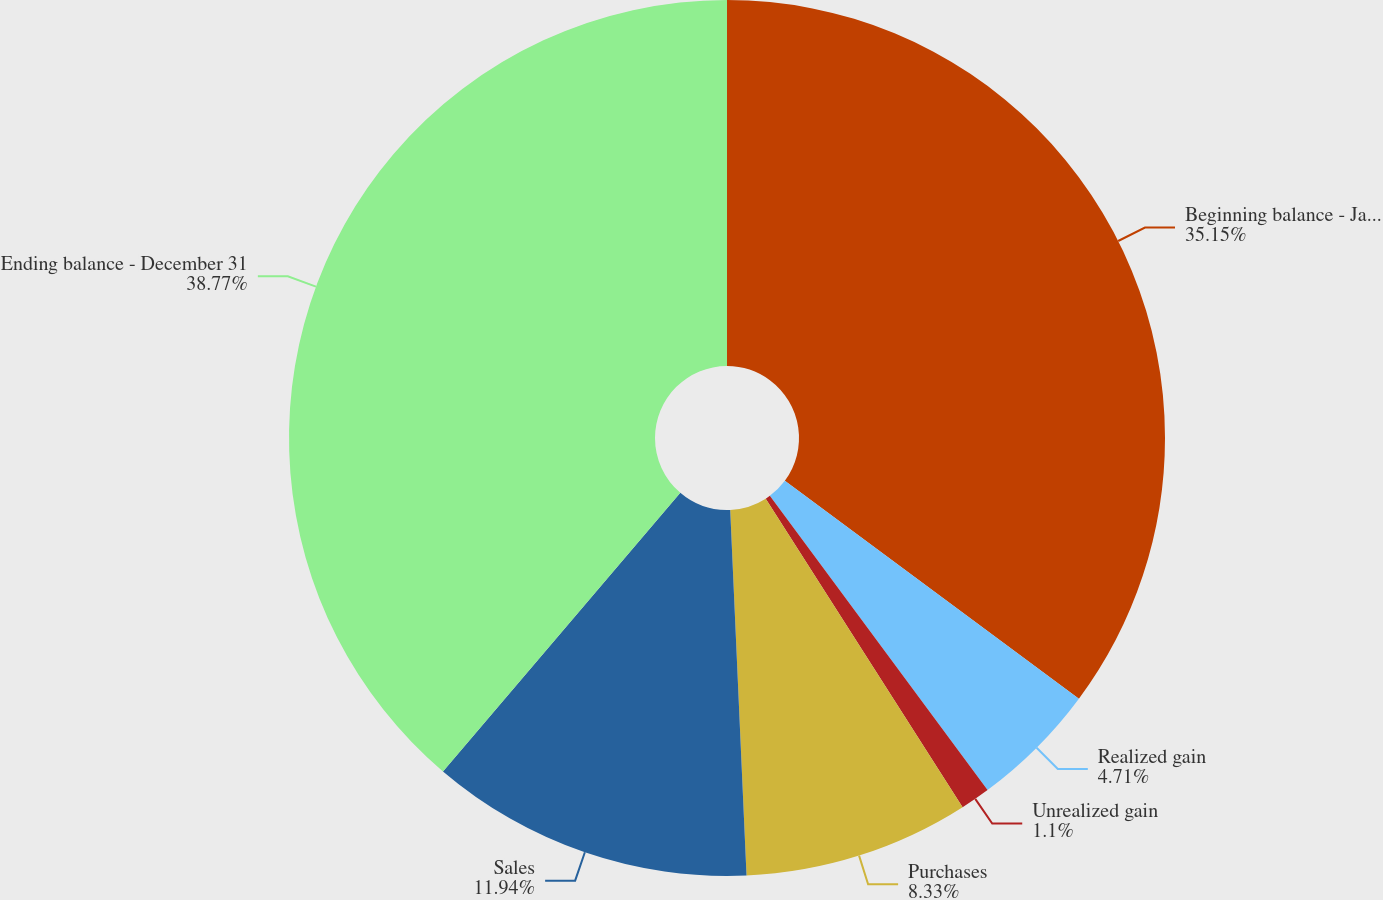<chart> <loc_0><loc_0><loc_500><loc_500><pie_chart><fcel>Beginning balance - January 1<fcel>Realized gain<fcel>Unrealized gain<fcel>Purchases<fcel>Sales<fcel>Ending balance - December 31<nl><fcel>35.15%<fcel>4.71%<fcel>1.1%<fcel>8.33%<fcel>11.94%<fcel>38.77%<nl></chart> 